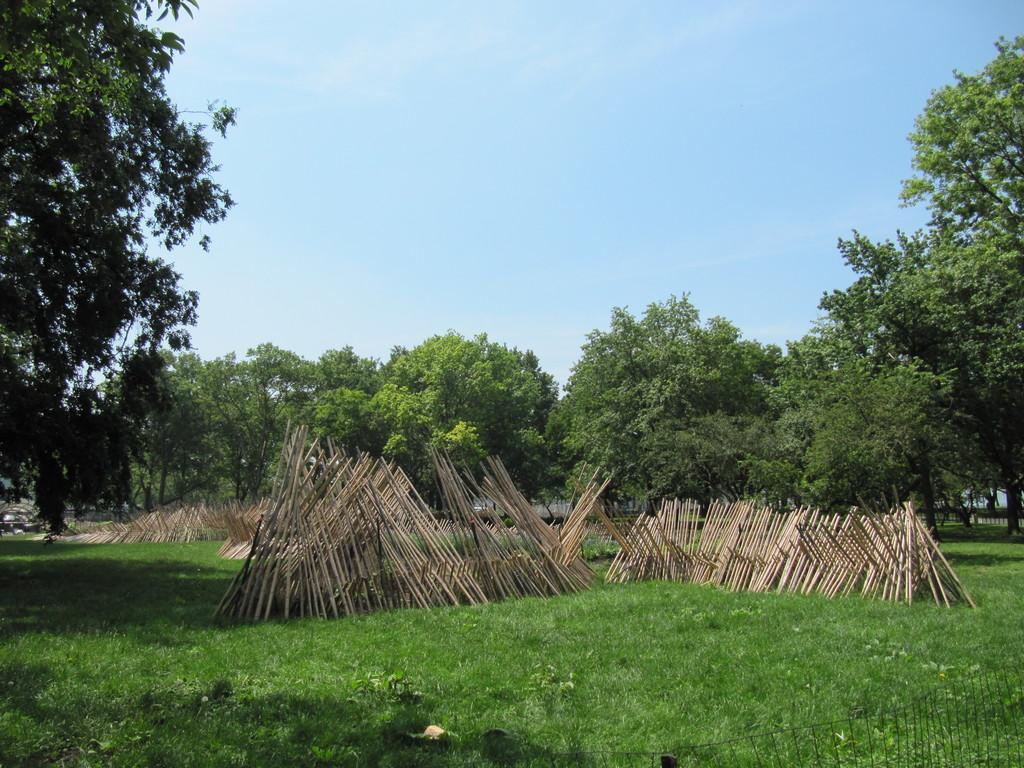Could you give a brief overview of what you see in this image? In this picture there are trees. In the foreground there are sticks and there is a fence. At the top there is sky. At the bottom there is grass. 